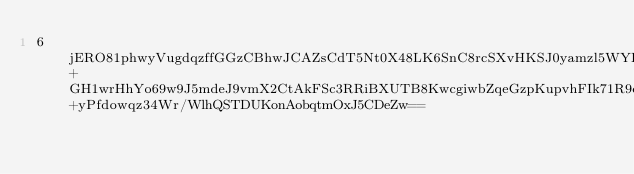Convert code to text. <code><loc_0><loc_0><loc_500><loc_500><_SML_>6jERO81phwyVugdqzffGGzCBhwJCAZsCdT5Nt0X48LK6SnC8rcSXvHKSJ0yamzl5WYI2lh6qMICu8KpKuiLHCrysf+GH1wrHhYo69w9J5mdeJ9vmX2CtAkFSc3RRiBXUTB8KwcgiwbZqeGzpKupvhFIk71R9ciBa8VLvT1+yPfdowqz34Wr/WlhQSTDUKonAobqtmOxJ5CDeZw==</code> 